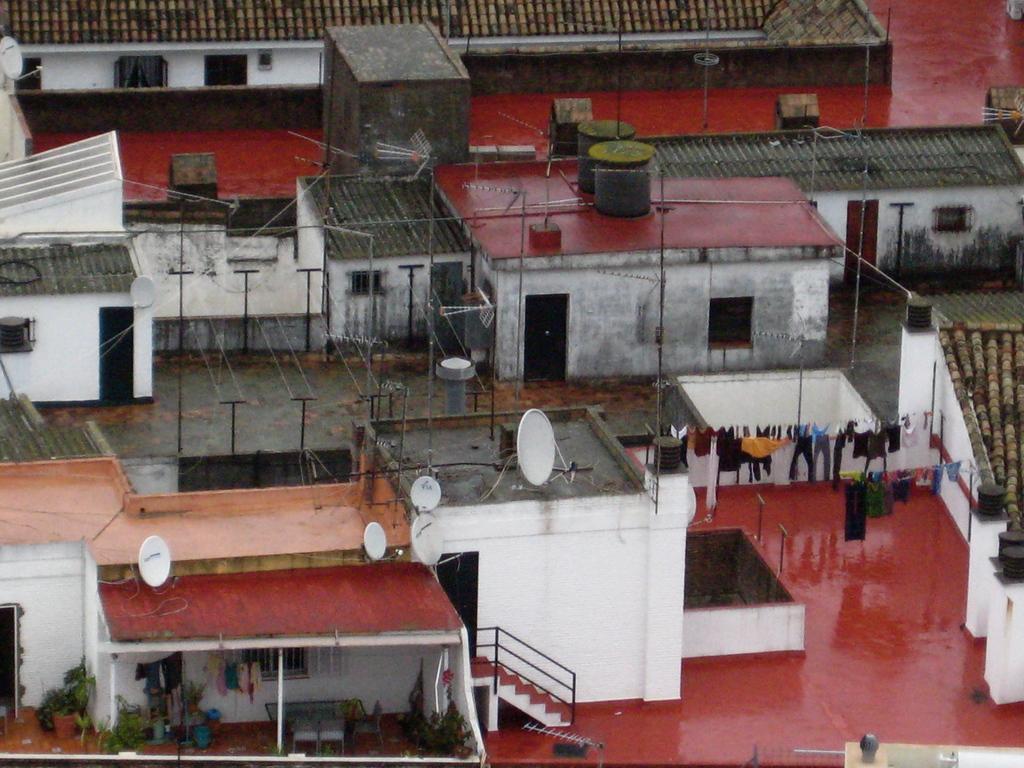How would you summarize this image in a sentence or two? In this picture we can see buildings with windows, poles, clothes, steps, house plants, table, chairs. 